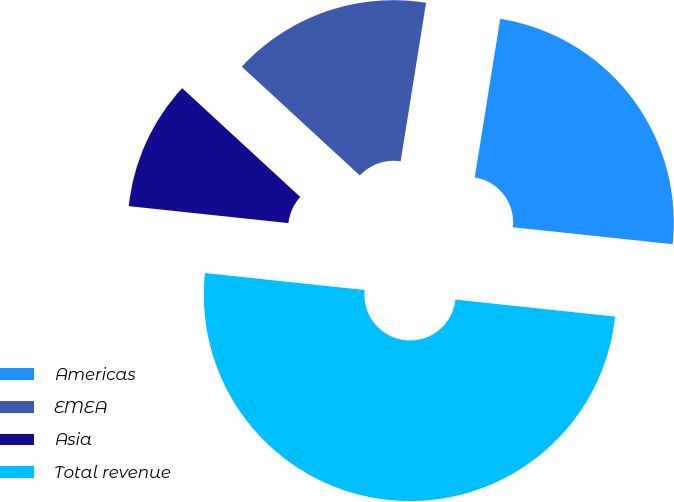Convert chart to OTSL. <chart><loc_0><loc_0><loc_500><loc_500><pie_chart><fcel>Americas<fcel>EMEA<fcel>Asia<fcel>Total revenue<nl><fcel>24.15%<fcel>15.68%<fcel>10.17%<fcel>50.0%<nl></chart> 